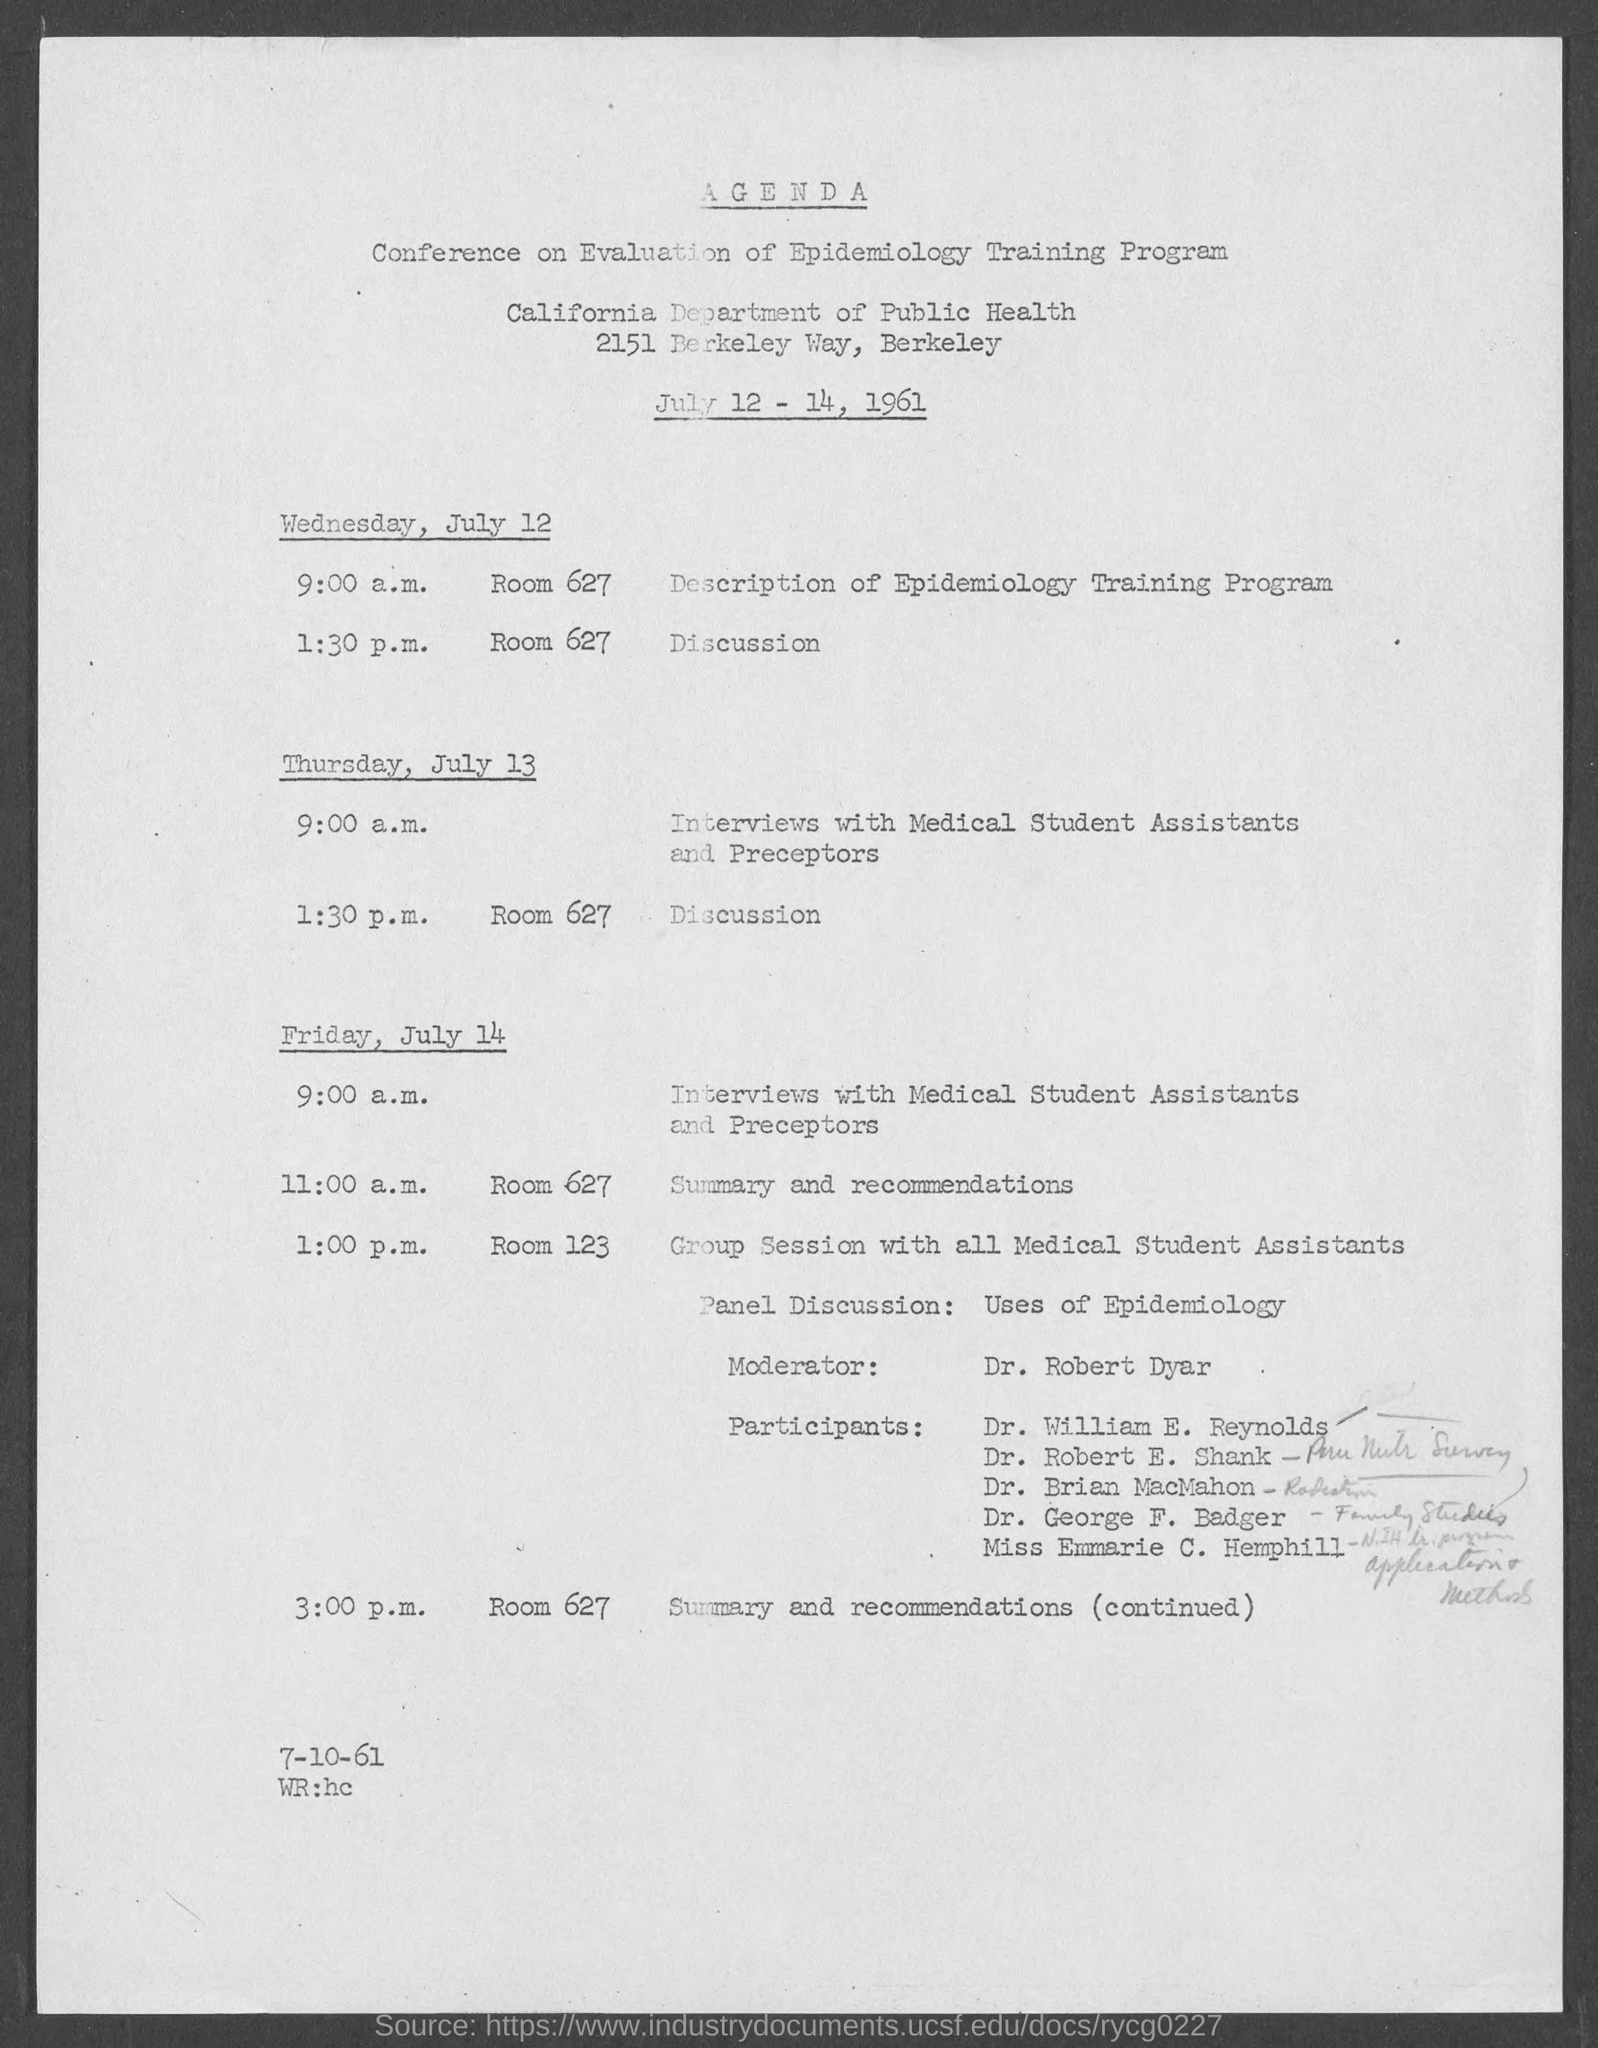Highlight a few significant elements in this photo. Dr. Robert Dyar is the moderator in the group session with all medical assistants. The interviews with medical student assistants and preceptors are scheduled for Friday, July 14 at 9:00 A.M. The discussions are scheduled to take place on Wednesday, July 12, in ROOM 627. The description of the Epidemiology Training program will be held on Wednesday, July 12, at 9:00 A.M. The Conference on the Evaluation of Epidemiology Training Program was held from July 12 to 14, 1961. 